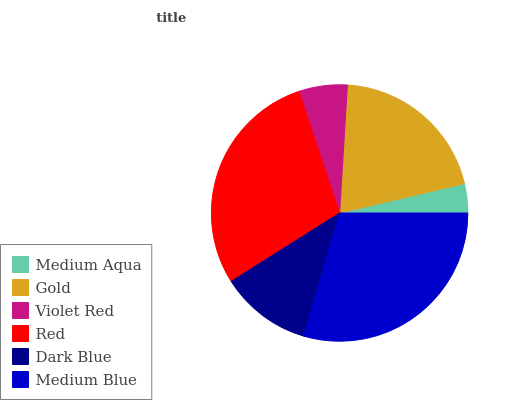Is Medium Aqua the minimum?
Answer yes or no. Yes. Is Medium Blue the maximum?
Answer yes or no. Yes. Is Gold the minimum?
Answer yes or no. No. Is Gold the maximum?
Answer yes or no. No. Is Gold greater than Medium Aqua?
Answer yes or no. Yes. Is Medium Aqua less than Gold?
Answer yes or no. Yes. Is Medium Aqua greater than Gold?
Answer yes or no. No. Is Gold less than Medium Aqua?
Answer yes or no. No. Is Gold the high median?
Answer yes or no. Yes. Is Dark Blue the low median?
Answer yes or no. Yes. Is Medium Blue the high median?
Answer yes or no. No. Is Violet Red the low median?
Answer yes or no. No. 